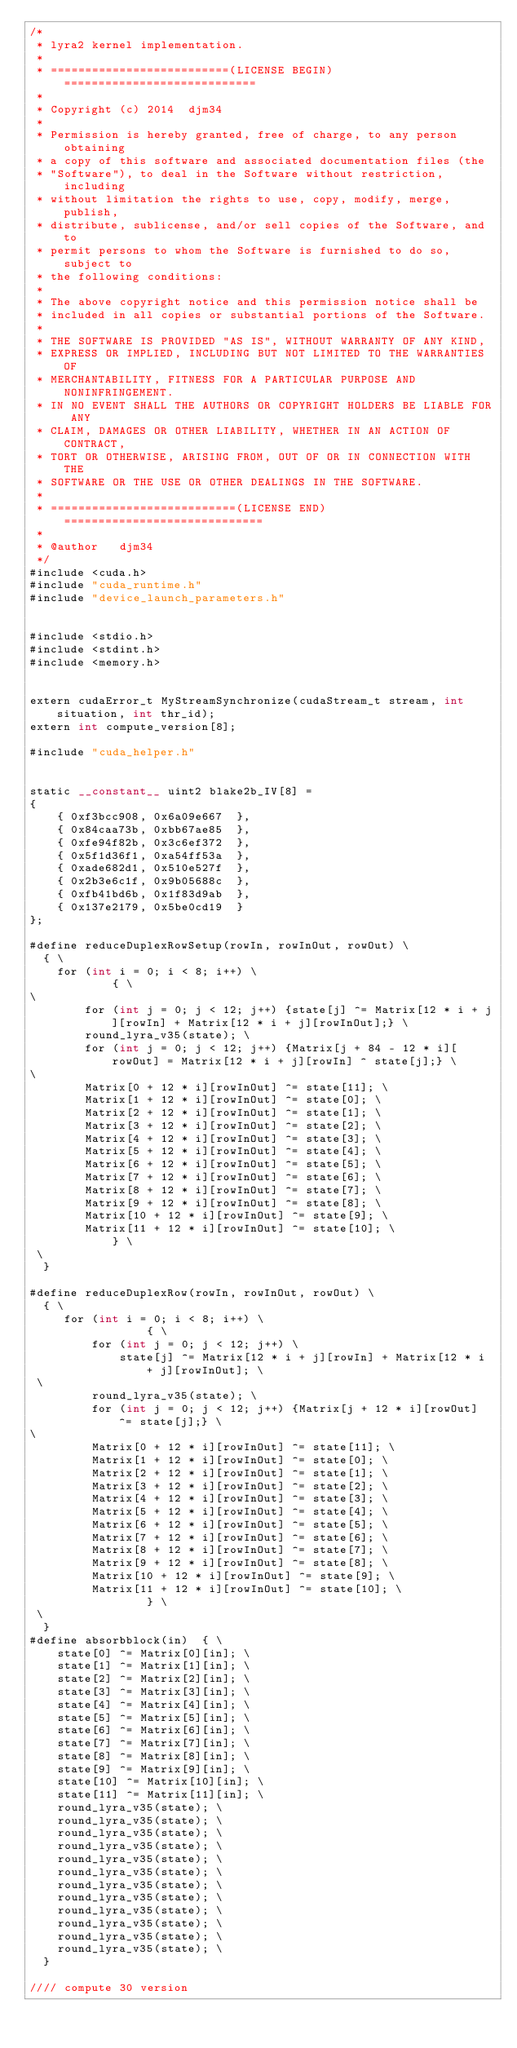Convert code to text. <code><loc_0><loc_0><loc_500><loc_500><_Cuda_>/*
 * lyra2 kernel implementation.
 *
 * ==========================(LICENSE BEGIN)============================
 *
 * Copyright (c) 2014  djm34
 * 
 * Permission is hereby granted, free of charge, to any person obtaining
 * a copy of this software and associated documentation files (the
 * "Software"), to deal in the Software without restriction, including
 * without limitation the rights to use, copy, modify, merge, publish,
 * distribute, sublicense, and/or sell copies of the Software, and to
 * permit persons to whom the Software is furnished to do so, subject to
 * the following conditions:
 * 
 * The above copyright notice and this permission notice shall be
 * included in all copies or substantial portions of the Software.
 * 
 * THE SOFTWARE IS PROVIDED "AS IS", WITHOUT WARRANTY OF ANY KIND,
 * EXPRESS OR IMPLIED, INCLUDING BUT NOT LIMITED TO THE WARRANTIES OF
 * MERCHANTABILITY, FITNESS FOR A PARTICULAR PURPOSE AND NONINFRINGEMENT.
 * IN NO EVENT SHALL THE AUTHORS OR COPYRIGHT HOLDERS BE LIABLE FOR ANY
 * CLAIM, DAMAGES OR OTHER LIABILITY, WHETHER IN AN ACTION OF CONTRACT,
 * TORT OR OTHERWISE, ARISING FROM, OUT OF OR IN CONNECTION WITH THE
 * SOFTWARE OR THE USE OR OTHER DEALINGS IN THE SOFTWARE.
 *
 * ===========================(LICENSE END)=============================
 *
 * @author   djm34
 */
#include <cuda.h>
#include "cuda_runtime.h"
#include "device_launch_parameters.h"


#include <stdio.h>
#include <stdint.h>
#include <memory.h>


extern cudaError_t MyStreamSynchronize(cudaStream_t stream, int situation, int thr_id);
extern int compute_version[8];

#include "cuda_helper.h"


static __constant__ uint2 blake2b_IV[8] =
{
	{ 0xf3bcc908, 0x6a09e667  }, 
	{ 0x84caa73b, 0xbb67ae85  },
	{ 0xfe94f82b, 0x3c6ef372  },
	{ 0x5f1d36f1, 0xa54ff53a  },
	{ 0xade682d1, 0x510e527f  },
	{ 0x2b3e6c1f, 0x9b05688c  },
	{ 0xfb41bd6b, 0x1f83d9ab  },
	{ 0x137e2179, 0x5be0cd19  }
};

#define reduceDuplexRowSetup(rowIn, rowInOut, rowOut) \
  { \
	for (int i = 0; i < 8; i++) \
			{ \
\
		for (int j = 0; j < 12; j++) {state[j] ^= Matrix[12 * i + j][rowIn] + Matrix[12 * i + j][rowInOut];} \
		round_lyra_v35(state); \
		for (int j = 0; j < 12; j++) {Matrix[j + 84 - 12 * i][rowOut] = Matrix[12 * i + j][rowIn] ^ state[j];} \
\
		Matrix[0 + 12 * i][rowInOut] ^= state[11]; \
		Matrix[1 + 12 * i][rowInOut] ^= state[0]; \
		Matrix[2 + 12 * i][rowInOut] ^= state[1]; \
		Matrix[3 + 12 * i][rowInOut] ^= state[2]; \
		Matrix[4 + 12 * i][rowInOut] ^= state[3]; \
		Matrix[5 + 12 * i][rowInOut] ^= state[4]; \
		Matrix[6 + 12 * i][rowInOut] ^= state[5]; \
		Matrix[7 + 12 * i][rowInOut] ^= state[6]; \
		Matrix[8 + 12 * i][rowInOut] ^= state[7]; \
		Matrix[9 + 12 * i][rowInOut] ^= state[8]; \
		Matrix[10 + 12 * i][rowInOut] ^= state[9]; \
		Matrix[11 + 12 * i][rowInOut] ^= state[10]; \
			} \
 \
  } 

#define reduceDuplexRow(rowIn, rowInOut, rowOut) \
  { \
	 for (int i = 0; i < 8; i++) \
	 	 	 	 { \
		 for (int j = 0; j < 12; j++) \
			 state[j] ^= Matrix[12 * i + j][rowIn] + Matrix[12 * i + j][rowInOut]; \
 \
		 round_lyra_v35(state); \
		 for (int j = 0; j < 12; j++) {Matrix[j + 12 * i][rowOut] ^= state[j];} \
\
		 Matrix[0 + 12 * i][rowInOut] ^= state[11]; \
		 Matrix[1 + 12 * i][rowInOut] ^= state[0]; \
		 Matrix[2 + 12 * i][rowInOut] ^= state[1]; \
		 Matrix[3 + 12 * i][rowInOut] ^= state[2]; \
		 Matrix[4 + 12 * i][rowInOut] ^= state[3]; \
		 Matrix[5 + 12 * i][rowInOut] ^= state[4]; \
		 Matrix[6 + 12 * i][rowInOut] ^= state[5]; \
		 Matrix[7 + 12 * i][rowInOut] ^= state[6]; \
		 Matrix[8 + 12 * i][rowInOut] ^= state[7]; \
		 Matrix[9 + 12 * i][rowInOut] ^= state[8]; \
		 Matrix[10 + 12 * i][rowInOut] ^= state[9]; \
		 Matrix[11 + 12 * i][rowInOut] ^= state[10]; \
	 	 	 	 } \
 \
  } 
#define absorbblock(in)  { \
	state[0] ^= Matrix[0][in]; \
	state[1] ^= Matrix[1][in]; \
	state[2] ^= Matrix[2][in]; \
	state[3] ^= Matrix[3][in]; \
	state[4] ^= Matrix[4][in]; \
	state[5] ^= Matrix[5][in]; \
	state[6] ^= Matrix[6][in]; \
	state[7] ^= Matrix[7][in]; \
	state[8] ^= Matrix[8][in]; \
	state[9] ^= Matrix[9][in]; \
	state[10] ^= Matrix[10][in]; \
	state[11] ^= Matrix[11][in]; \
	round_lyra_v35(state); \
	round_lyra_v35(state); \
	round_lyra_v35(state); \
	round_lyra_v35(state); \
	round_lyra_v35(state); \
	round_lyra_v35(state); \
	round_lyra_v35(state); \
	round_lyra_v35(state); \
	round_lyra_v35(state); \
	round_lyra_v35(state); \
	round_lyra_v35(state); \
	round_lyra_v35(state); \
  } 

//// compute 30 version </code> 